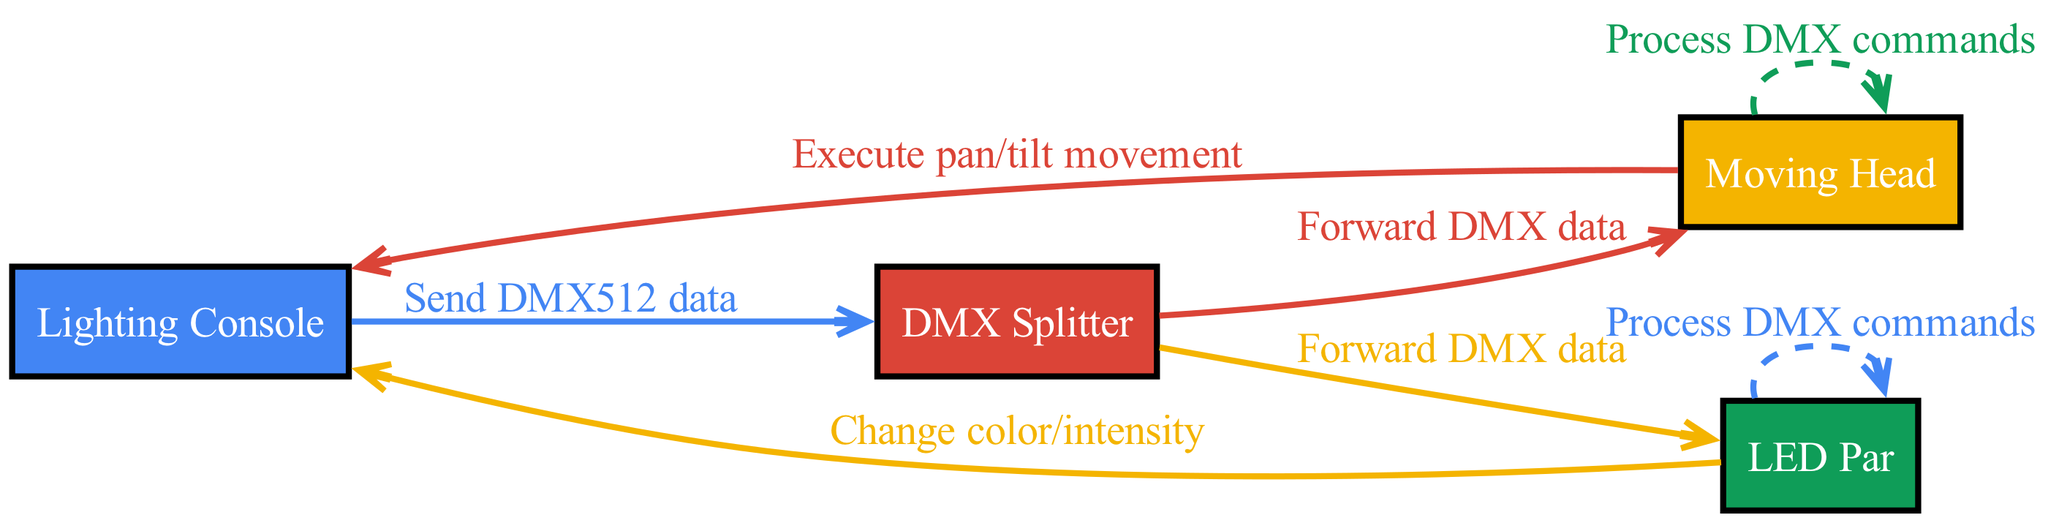What is the total number of actors in the diagram? There are four actors represented in the diagram: Lighting Console, DMX Splitter, Moving Head, and LED Par. By counting, we verify that four is the correct total.
Answer: four Which actor sends DMX512 data? The Lighting Console is the actor that sends DMX512 data, as indicated by the arrow originating from it towards the DMX Splitter with the corresponding message.
Answer: Lighting Console How many messages are sent from the DMX Splitter? The DMX Splitter forwards DMX data to both the Moving Head and the LED Par. Each of these connections represents a message, leading us to a total of two messages sent from the DMX Splitter.
Answer: two What type of command does the Moving Head process? The Moving Head processes DMX commands, as shown by the self-message labeled "Process DMX commands", suggesting it reacts to incoming DMX data accordingly.
Answer: DMX commands Which actor is responsible for executing pan and tilt movement? The Moving Head is responsible for executing pan and tilt movement, as seen from the message directed back to the Lighting Console stating "Execute pan/tilt movement".
Answer: Moving Head What is the relationship between the DMX Splitter and the LED Par? The DMX Splitter forwards DMX data to the LED Par, which establishes a direct communication link where the LED Par receives the necessary data to operate.
Answer: forwards What is the significance of the dashed arrow from the Moving Head to itself? The dashed arrow indicates that the Moving Head processes its own DMX commands, showing a self-referential action that signifies internal processing of received data.
Answer: internal processing How many total messages are processed by the LED Par? The LED Par processes its own DMX commands as indicated by a self-message and also receives data from the DMX Splitter. Thus, two messages are involved in total.
Answer: two 